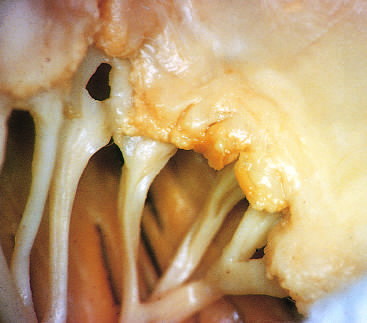have the effector arms of these central circuits caused fibrous thickening and fusion of the chordae tendineae?
Answer the question using a single word or phrase. No 